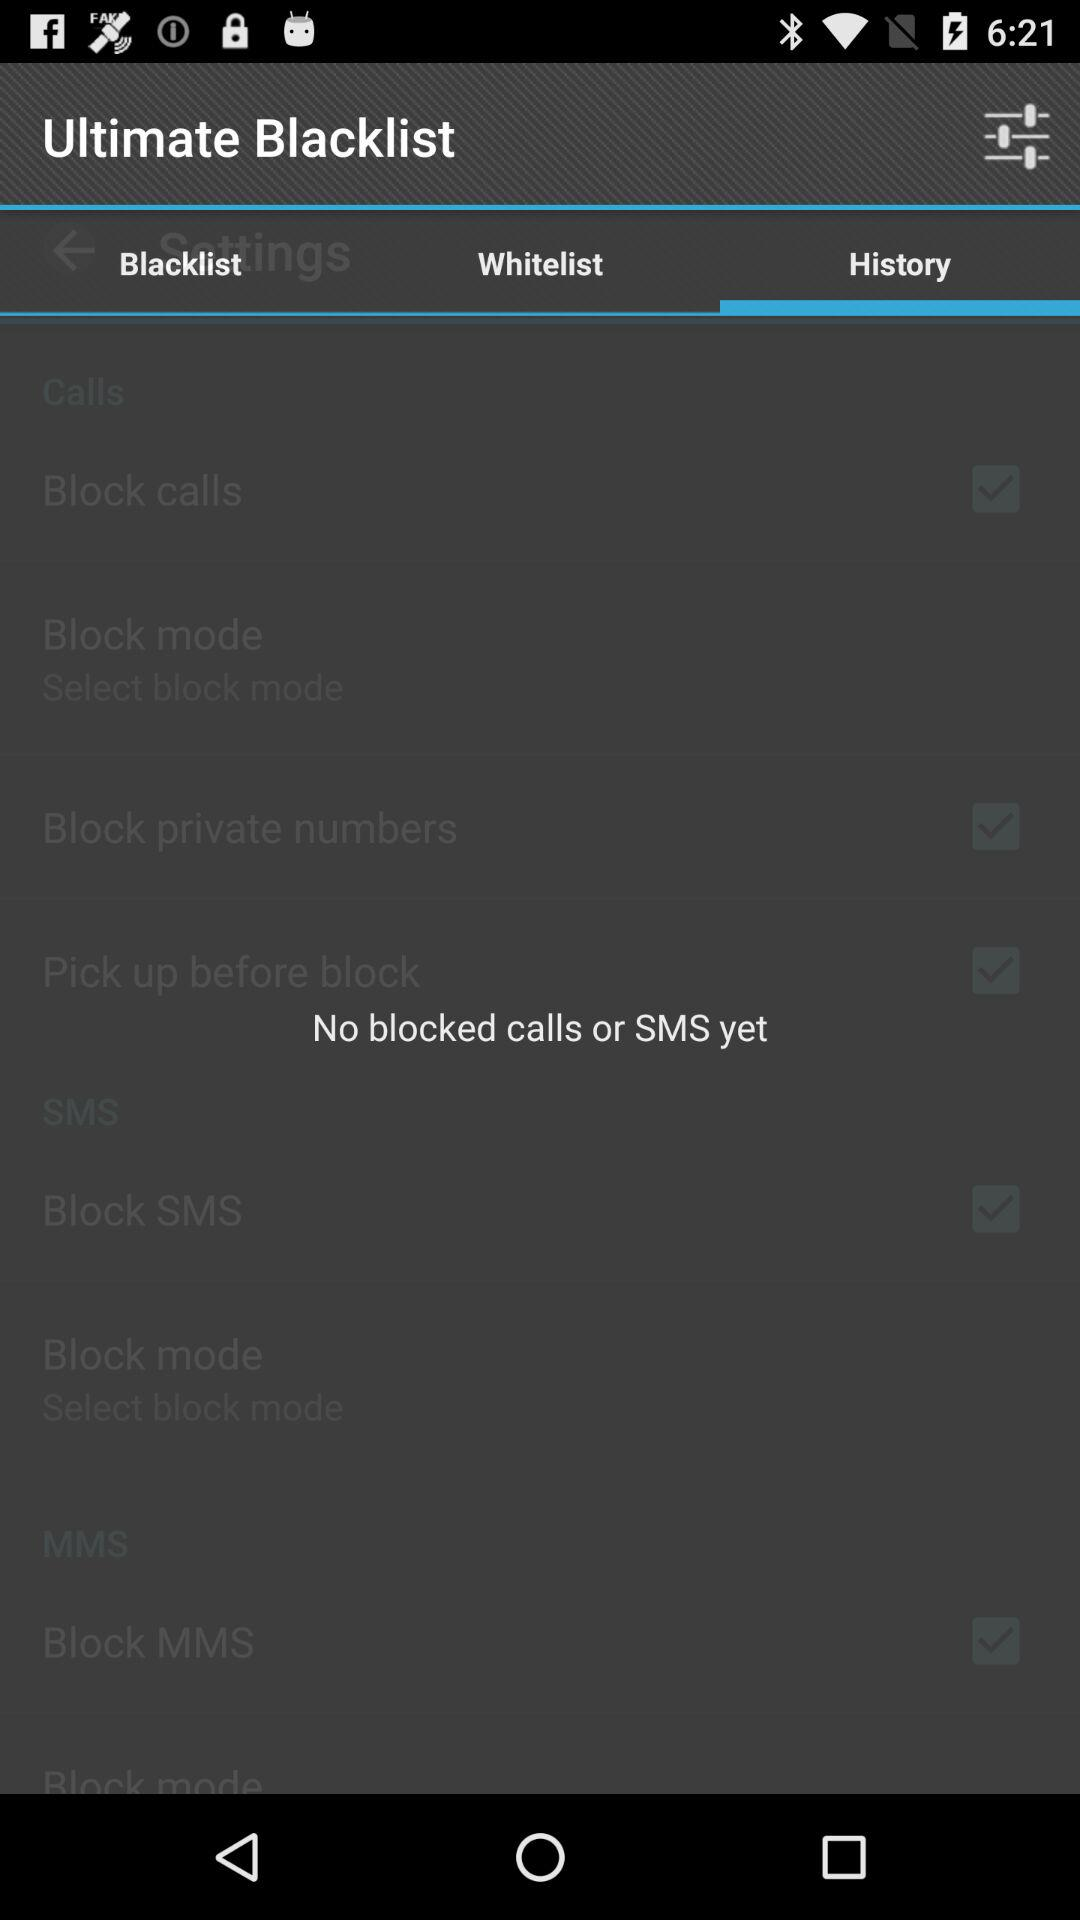Are there any blocked calls or SMS yet? There are no blocked calls or SMS yet. 